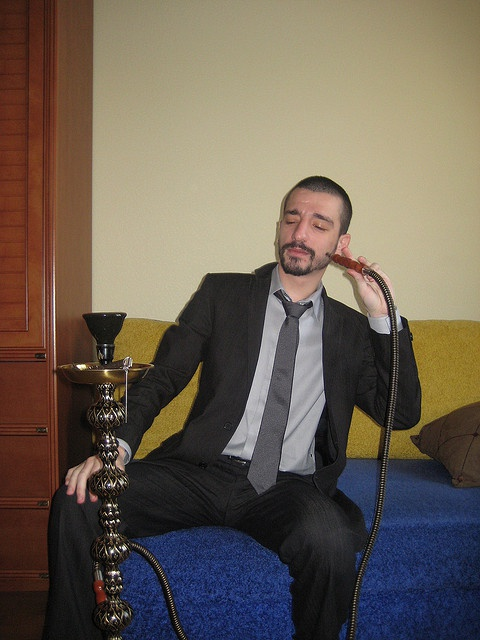Describe the objects in this image and their specific colors. I can see people in black, darkgray, gray, and tan tones, couch in black, navy, olive, and darkblue tones, and tie in black, gray, and darkgray tones in this image. 